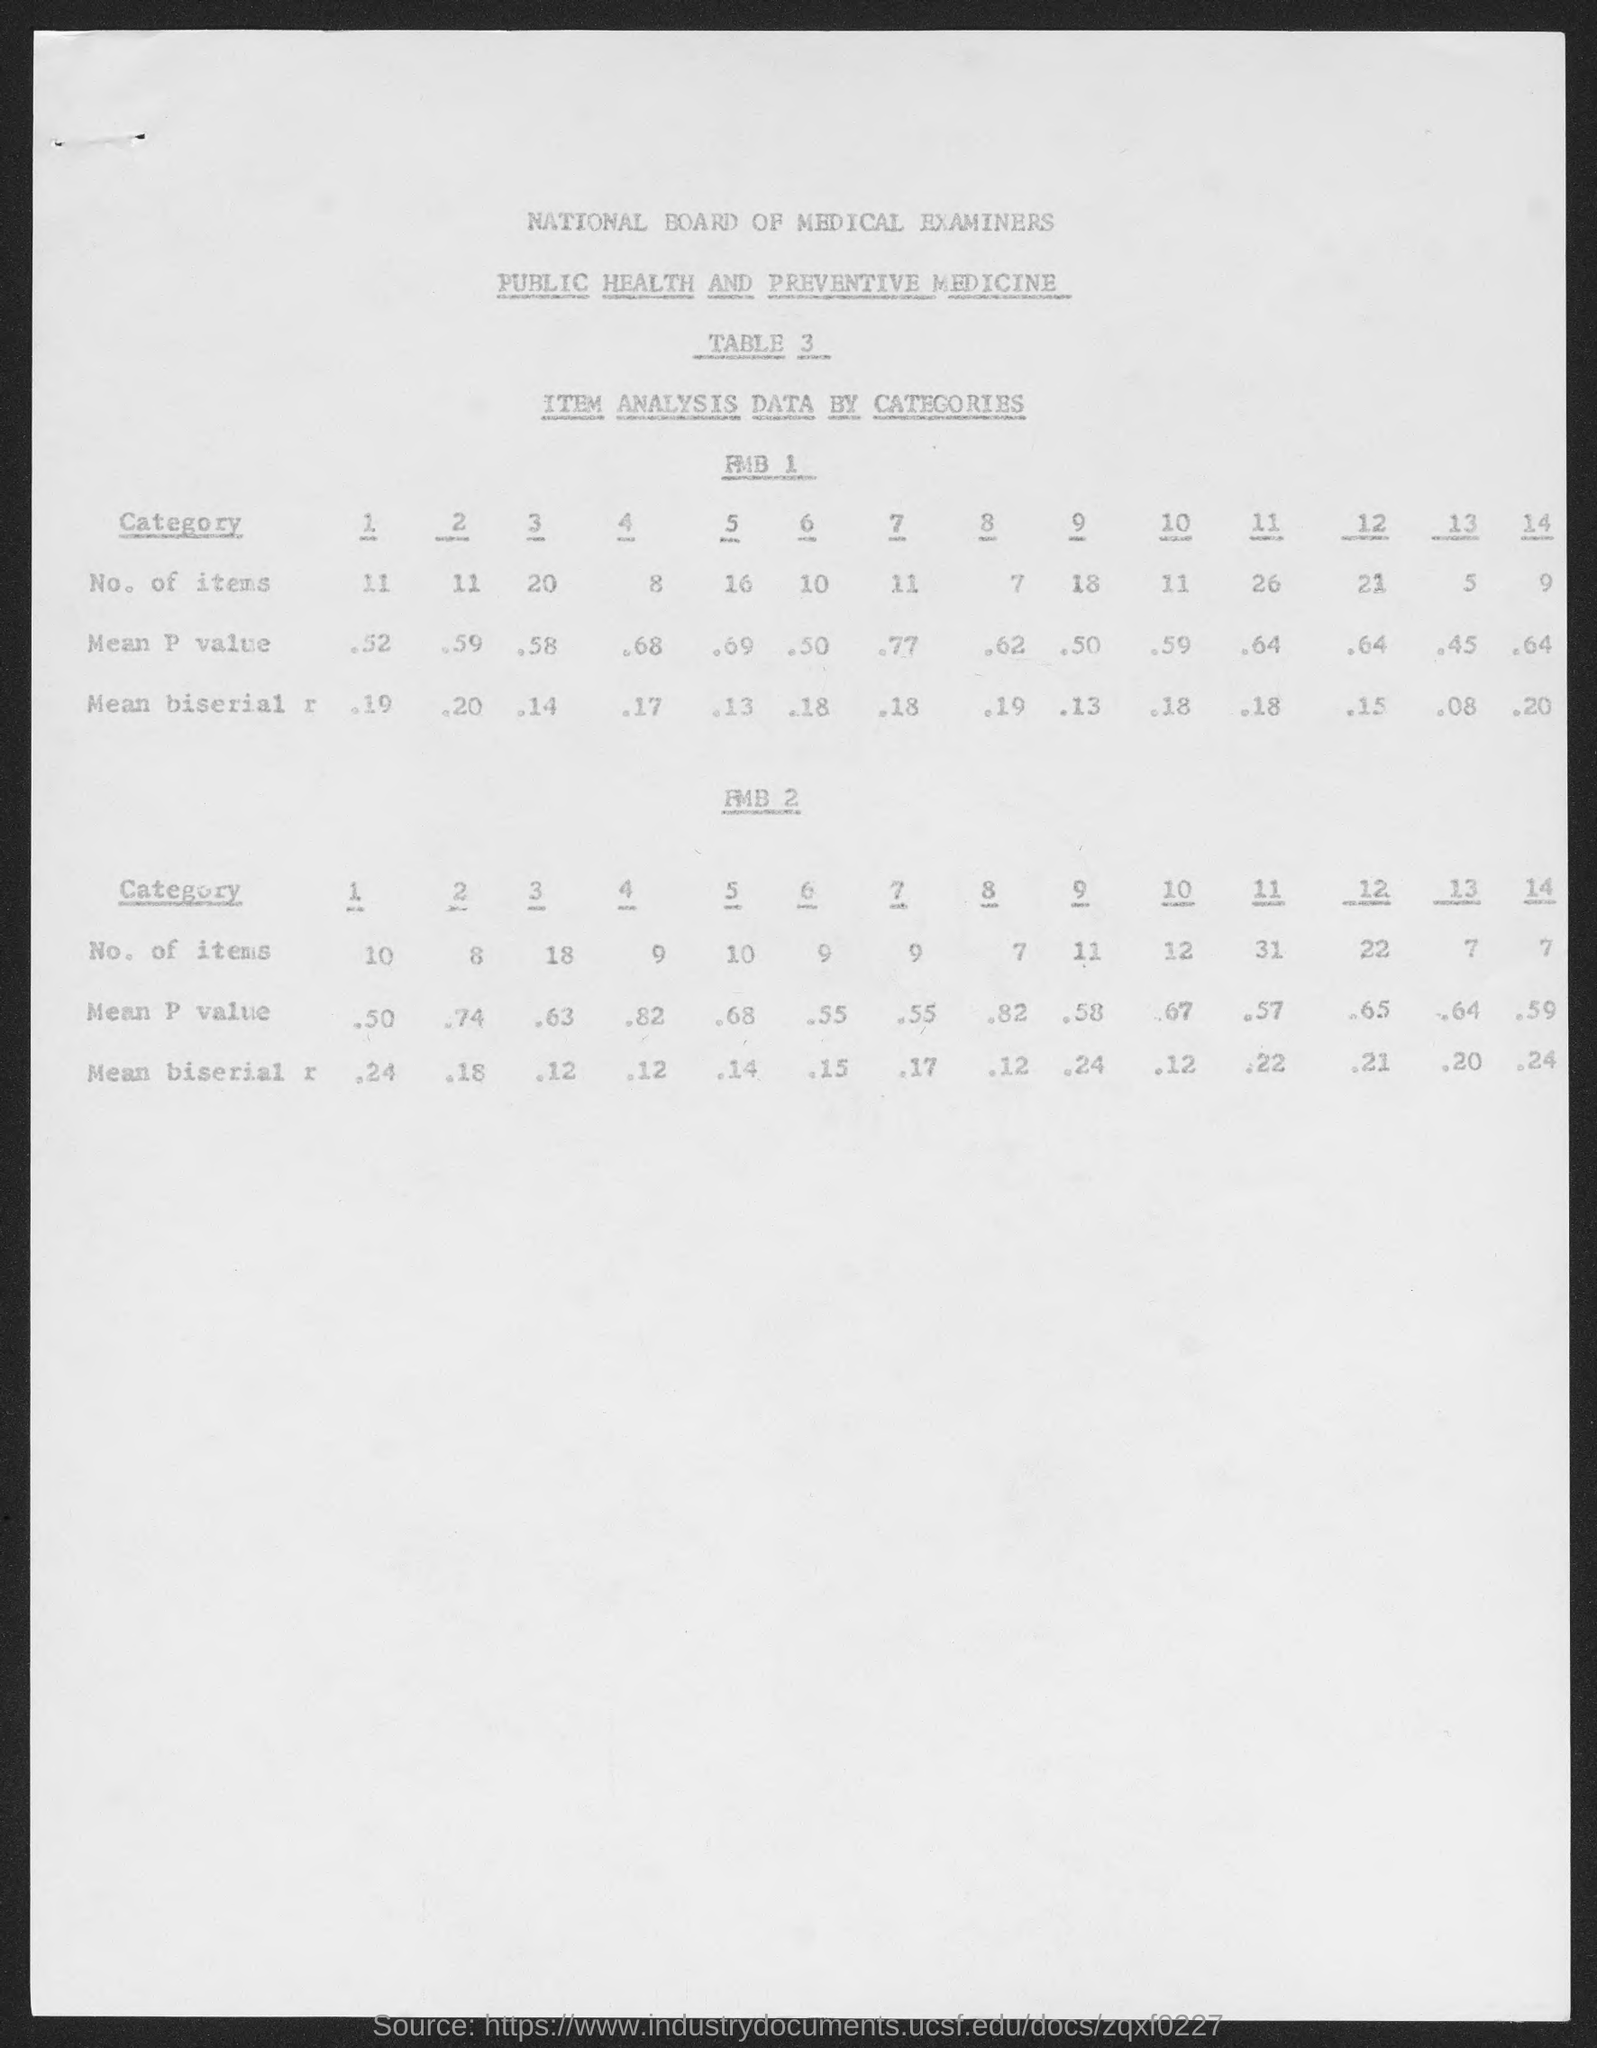Indicate a few pertinent items in this graphic. The National Board of Medical Examiners is the board in question. 